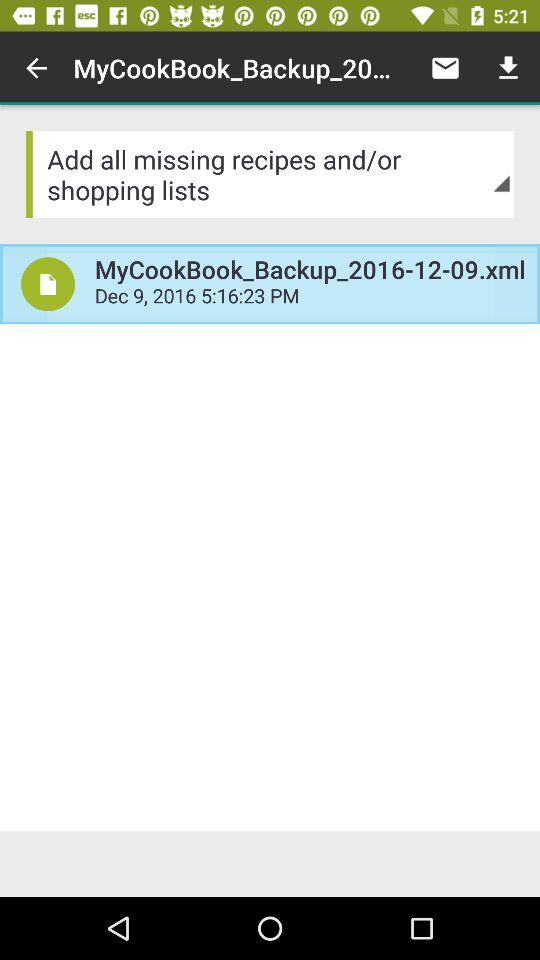How many minutes after 5pm was the backup created?
Answer the question using a single word or phrase. 16 